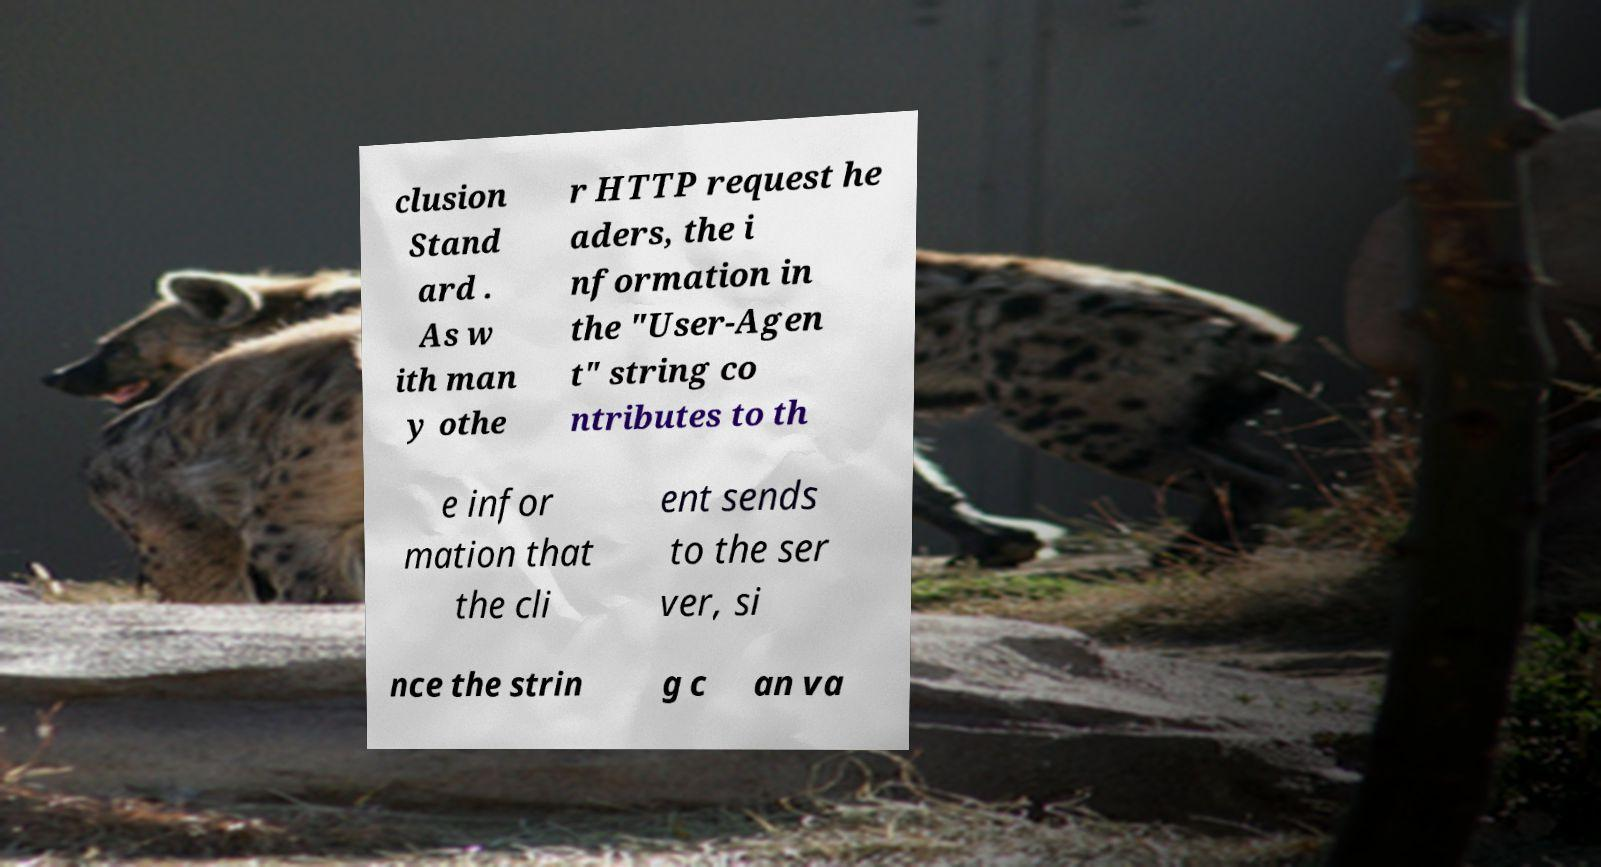Could you extract and type out the text from this image? clusion Stand ard . As w ith man y othe r HTTP request he aders, the i nformation in the "User-Agen t" string co ntributes to th e infor mation that the cli ent sends to the ser ver, si nce the strin g c an va 